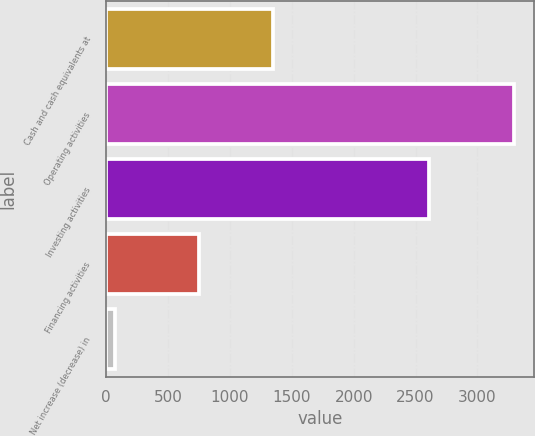Convert chart. <chart><loc_0><loc_0><loc_500><loc_500><bar_chart><fcel>Cash and cash equivalents at<fcel>Operating activities<fcel>Investing activities<fcel>Financing activities<fcel>Net increase (decrease) in<nl><fcel>1351<fcel>3291<fcel>2609<fcel>753<fcel>71<nl></chart> 